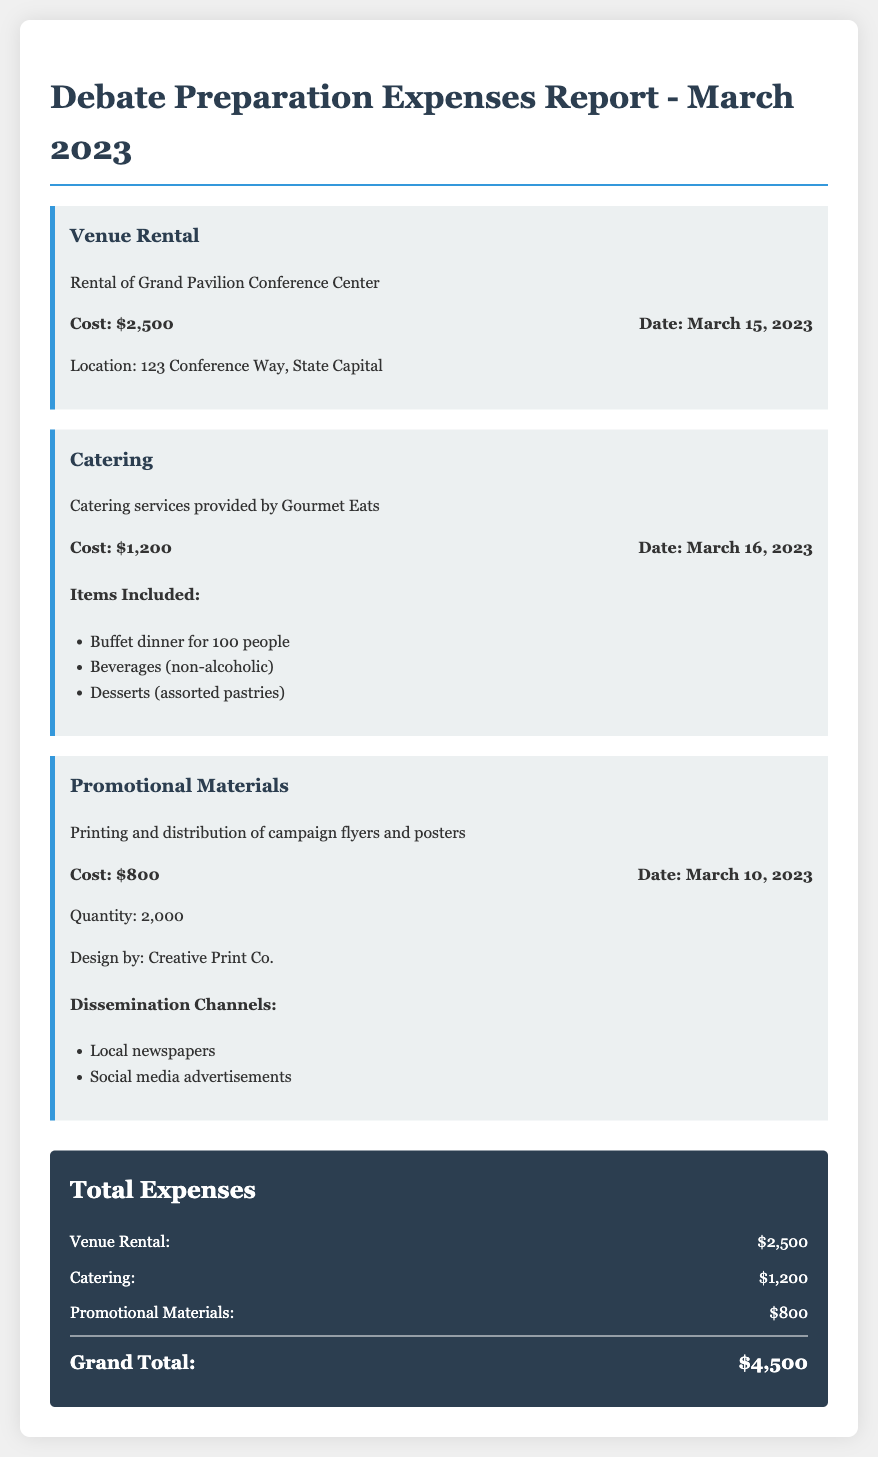What was the venue rental cost? The document states that the cost for venue rental of the Grand Pavilion Conference Center is $2,500.
Answer: $2,500 When was the catering service provided? According to the report, the catering service by Gourmet Eats was provided on March 16, 2023.
Answer: March 16, 2023 How many promotional materials were printed? The document mentions that 2,000 campaign flyers and posters were printed and distributed.
Answer: 2,000 What is the grand total of all expenses? The grand total is calculated by adding up all the individual expenses: $2,500 + $1,200 + $800 = $4,500.
Answer: $4,500 Who designed the promotional materials? The report specifies that the design was done by Creative Print Co.
Answer: Creative Print Co What items were included in the catering service? The document lists a buffet dinner, non-alcoholic beverages, and assorted pastries as included items in the catering service.
Answer: Buffet dinner for 100 people, Beverages (non-alcoholic), Desserts (assorted pastries) Where was the venue located? The report states that the location of the Grand Pavilion Conference Center is 123 Conference Way, State Capital.
Answer: 123 Conference Way, State Capital What channels were used for dissemination of the promotional materials? The document indicates that local newspapers and social media advertisements were the channels used for dissemination.
Answer: Local newspapers, Social media advertisements 